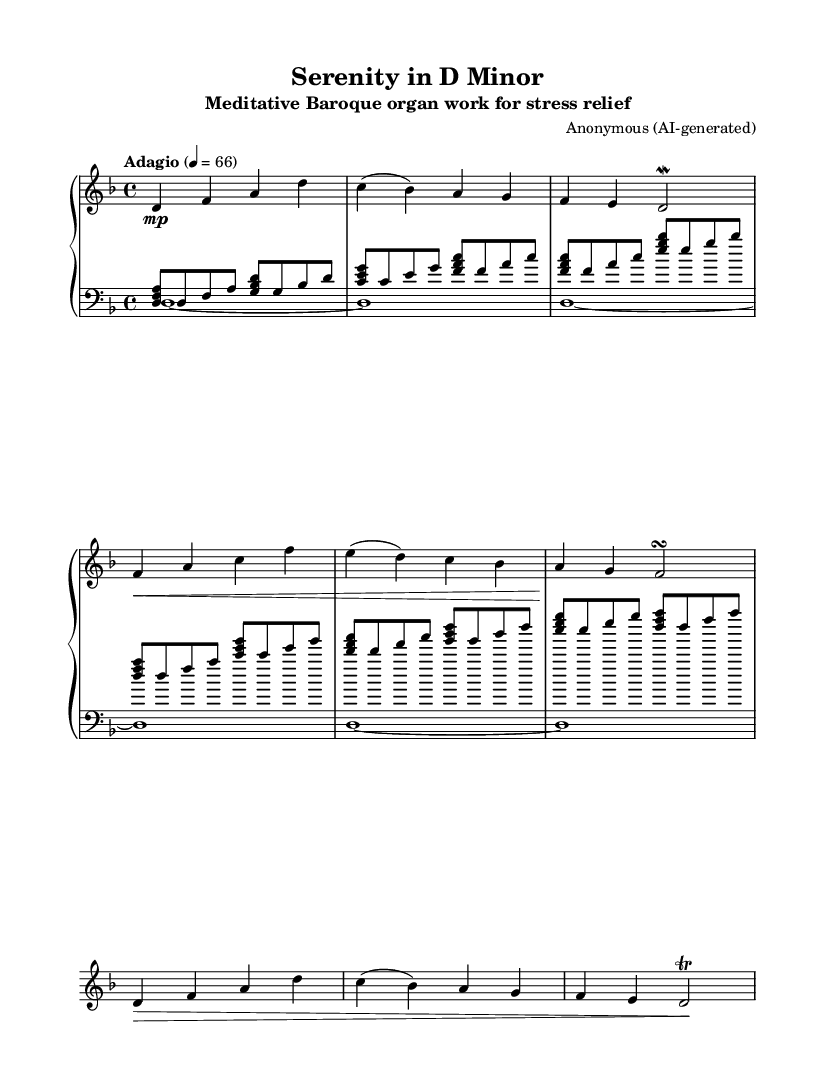What is the key signature of this music? The key signature is D minor, which has one flat (B flat). This can be identified by looking at the beginning of the staff where the flat is placed.
Answer: D minor What is the time signature of this music? The time signature is four-four, indicated by the "4/4" notation at the beginning of the piece, which means there are four beats in each measure.
Answer: 4/4 What is the tempo marking of the piece? The tempo marking is "Adagio," which generally indicates a slow tempo. It is shown at the start of the sheet music, along with the metronome marking of quarter note equals sixty-six.
Answer: Adagio How many sections are there in the piece? There are three distinct sections: A, B, and A'. The A section is repeated in the A' section, but the format is slightly modified.
Answer: 3 What ornament is utilized in the right hand in the second B section? The ornament used in the second B section is a turn, indicated by the symbol following the note F. This embellishment is characteristic of Baroque music.
Answer: Turn What type of musical texture does this piece exhibit? The piece exhibits a polyphonic texture, as demonstrated by the interplay of the right-hand melody and the left-hand arpeggiated chords, creating a rich, layered sound typical of Baroque organ music.
Answer: Polyphonic What is the dynamic marking found in the first A section? The dynamic marking in the first A section is "mp," which stands for "mezzo piano," indicating a moderately soft degree of loudness. This marking is found at the beginning of the A section.
Answer: mp 